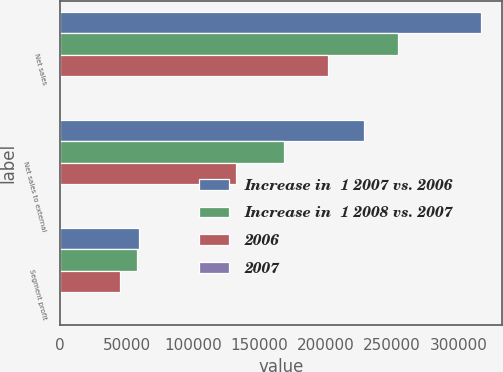<chart> <loc_0><loc_0><loc_500><loc_500><stacked_bar_chart><ecel><fcel>Net sales<fcel>Net sales to external<fcel>Segment profit<nl><fcel>Increase in  1 2007 vs. 2006<fcel>317040<fcel>228890<fcel>59027<nl><fcel>Increase in  1 2008 vs. 2007<fcel>254510<fcel>168261<fcel>57481<nl><fcel>2006<fcel>201431<fcel>132710<fcel>45160<nl><fcel>2007<fcel>25<fcel>36<fcel>3<nl></chart> 